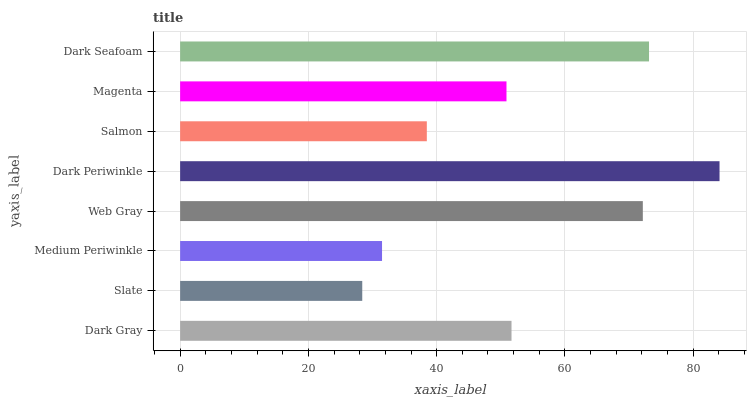Is Slate the minimum?
Answer yes or no. Yes. Is Dark Periwinkle the maximum?
Answer yes or no. Yes. Is Medium Periwinkle the minimum?
Answer yes or no. No. Is Medium Periwinkle the maximum?
Answer yes or no. No. Is Medium Periwinkle greater than Slate?
Answer yes or no. Yes. Is Slate less than Medium Periwinkle?
Answer yes or no. Yes. Is Slate greater than Medium Periwinkle?
Answer yes or no. No. Is Medium Periwinkle less than Slate?
Answer yes or no. No. Is Dark Gray the high median?
Answer yes or no. Yes. Is Magenta the low median?
Answer yes or no. Yes. Is Salmon the high median?
Answer yes or no. No. Is Medium Periwinkle the low median?
Answer yes or no. No. 